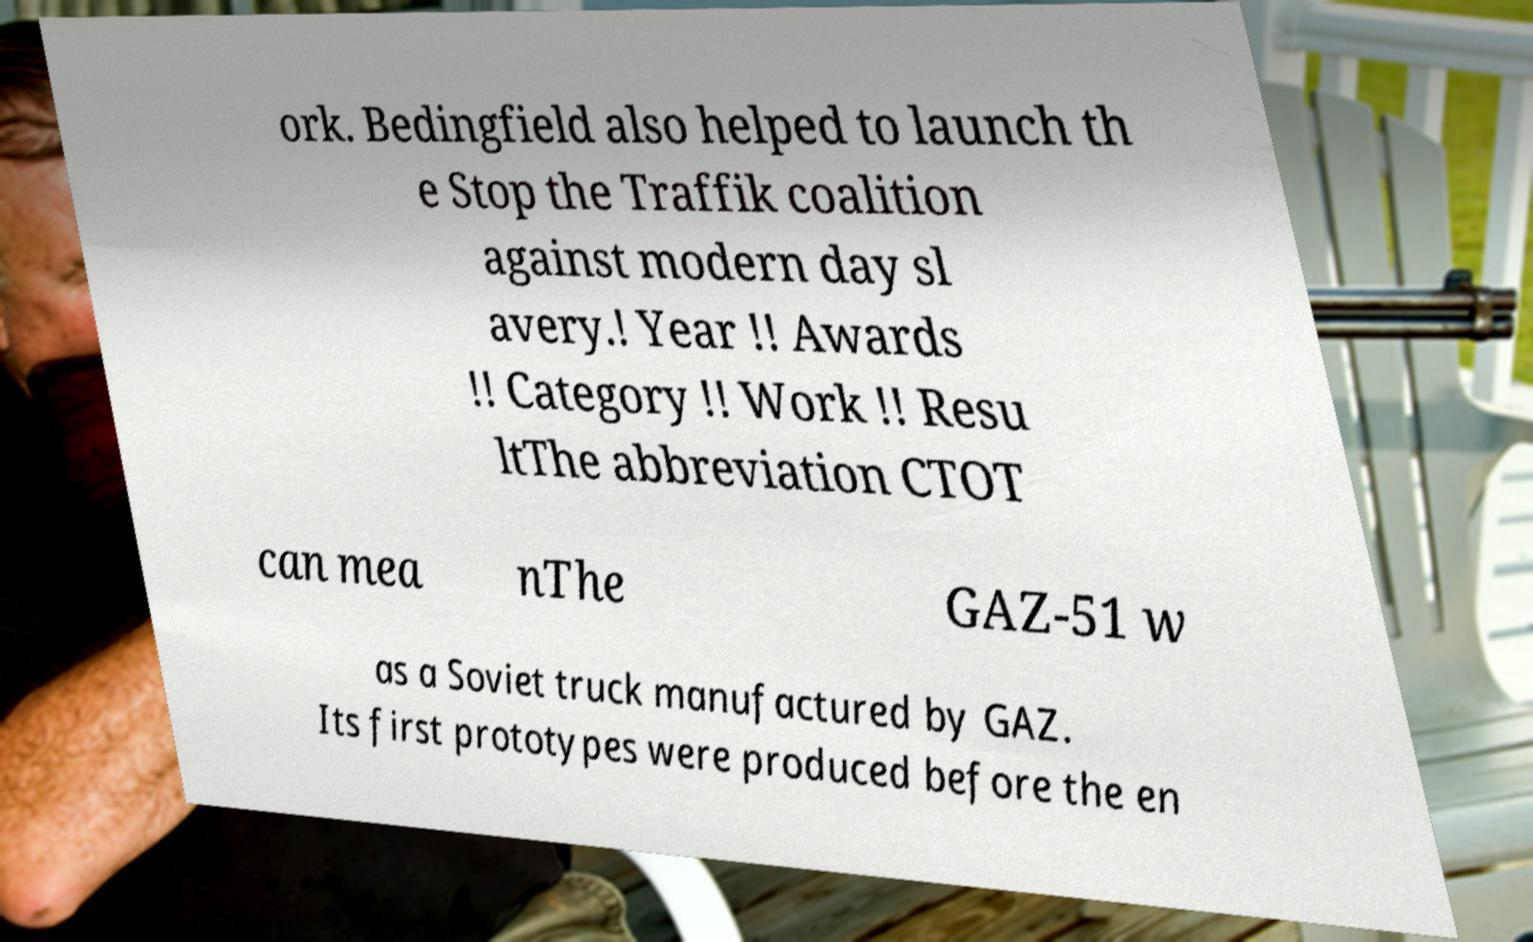There's text embedded in this image that I need extracted. Can you transcribe it verbatim? ork. Bedingfield also helped to launch th e Stop the Traffik coalition against modern day sl avery.! Year !! Awards !! Category !! Work !! Resu ltThe abbreviation CTOT can mea nThe GAZ-51 w as a Soviet truck manufactured by GAZ. Its first prototypes were produced before the en 